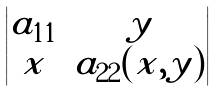<formula> <loc_0><loc_0><loc_500><loc_500>\begin{vmatrix} a _ { 1 1 } & y \\ x & a _ { 2 2 } ( x , y ) \end{vmatrix}</formula> 